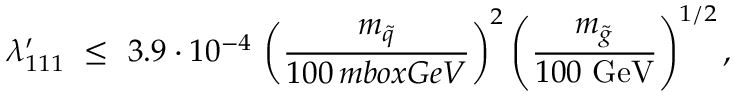<formula> <loc_0><loc_0><loc_500><loc_500>\lambda _ { 1 1 1 } ^ { \prime } \ \leq \ 3 . 9 \cdot 1 0 ^ { - 4 } \, \left ( \frac { m _ { \tilde { q } } } { 1 0 0 \, m b o x { G e V } } \right ) ^ { 2 } \left ( \frac { m _ { \tilde { g } } } { 1 0 0 \ G e V } \right ) ^ { 1 / 2 } ,</formula> 